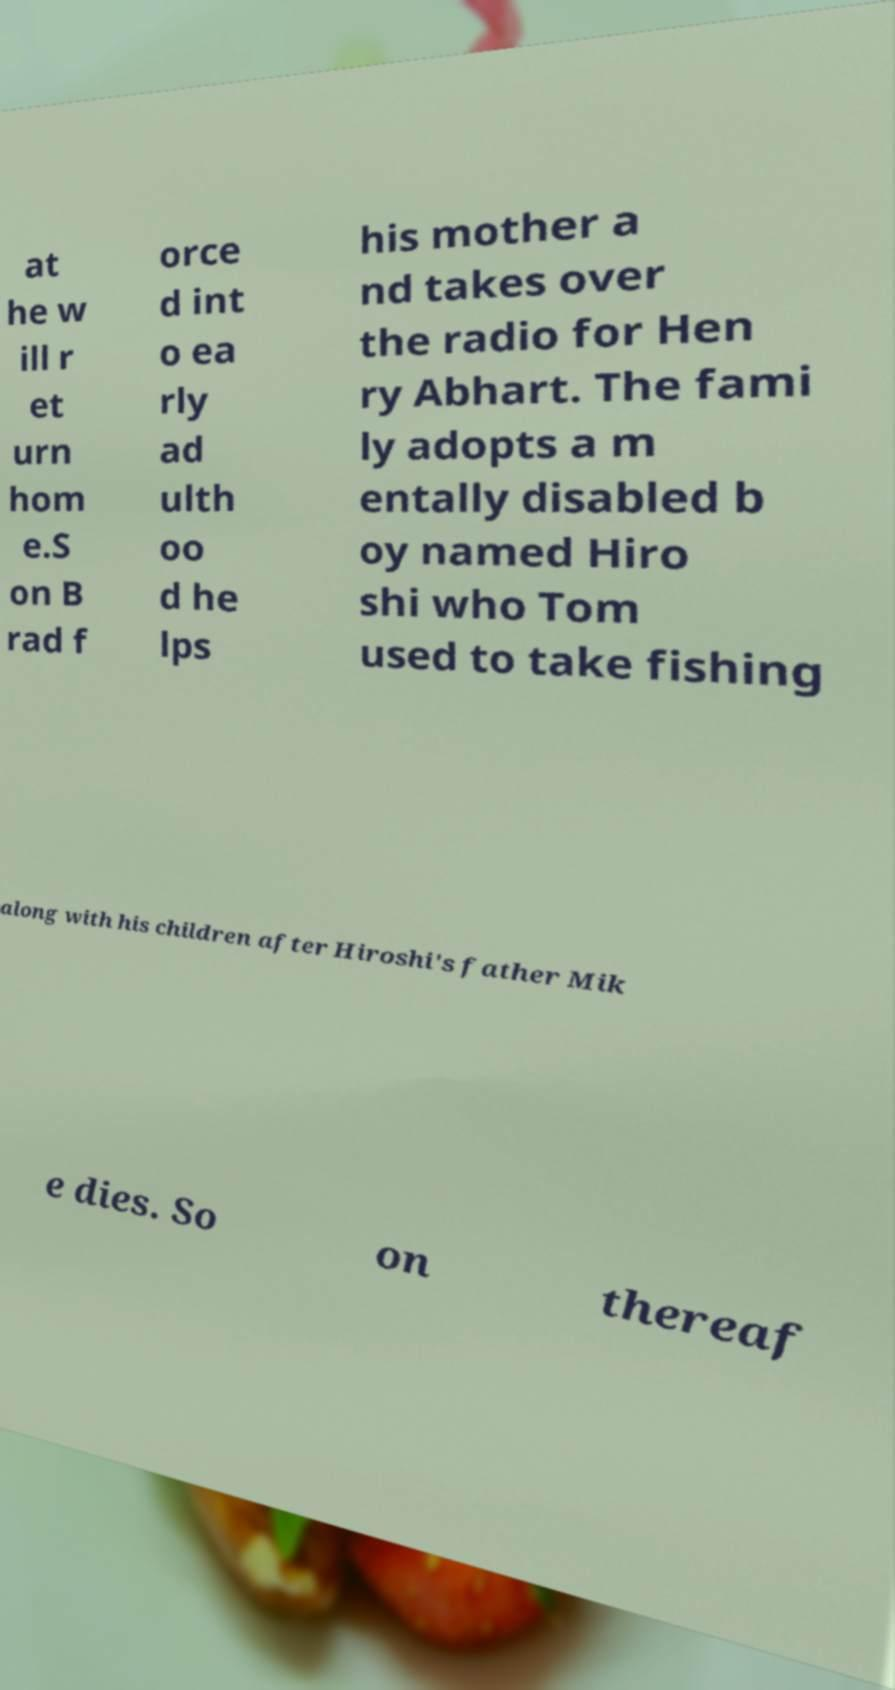There's text embedded in this image that I need extracted. Can you transcribe it verbatim? at he w ill r et urn hom e.S on B rad f orce d int o ea rly ad ulth oo d he lps his mother a nd takes over the radio for Hen ry Abhart. The fami ly adopts a m entally disabled b oy named Hiro shi who Tom used to take fishing along with his children after Hiroshi's father Mik e dies. So on thereaf 